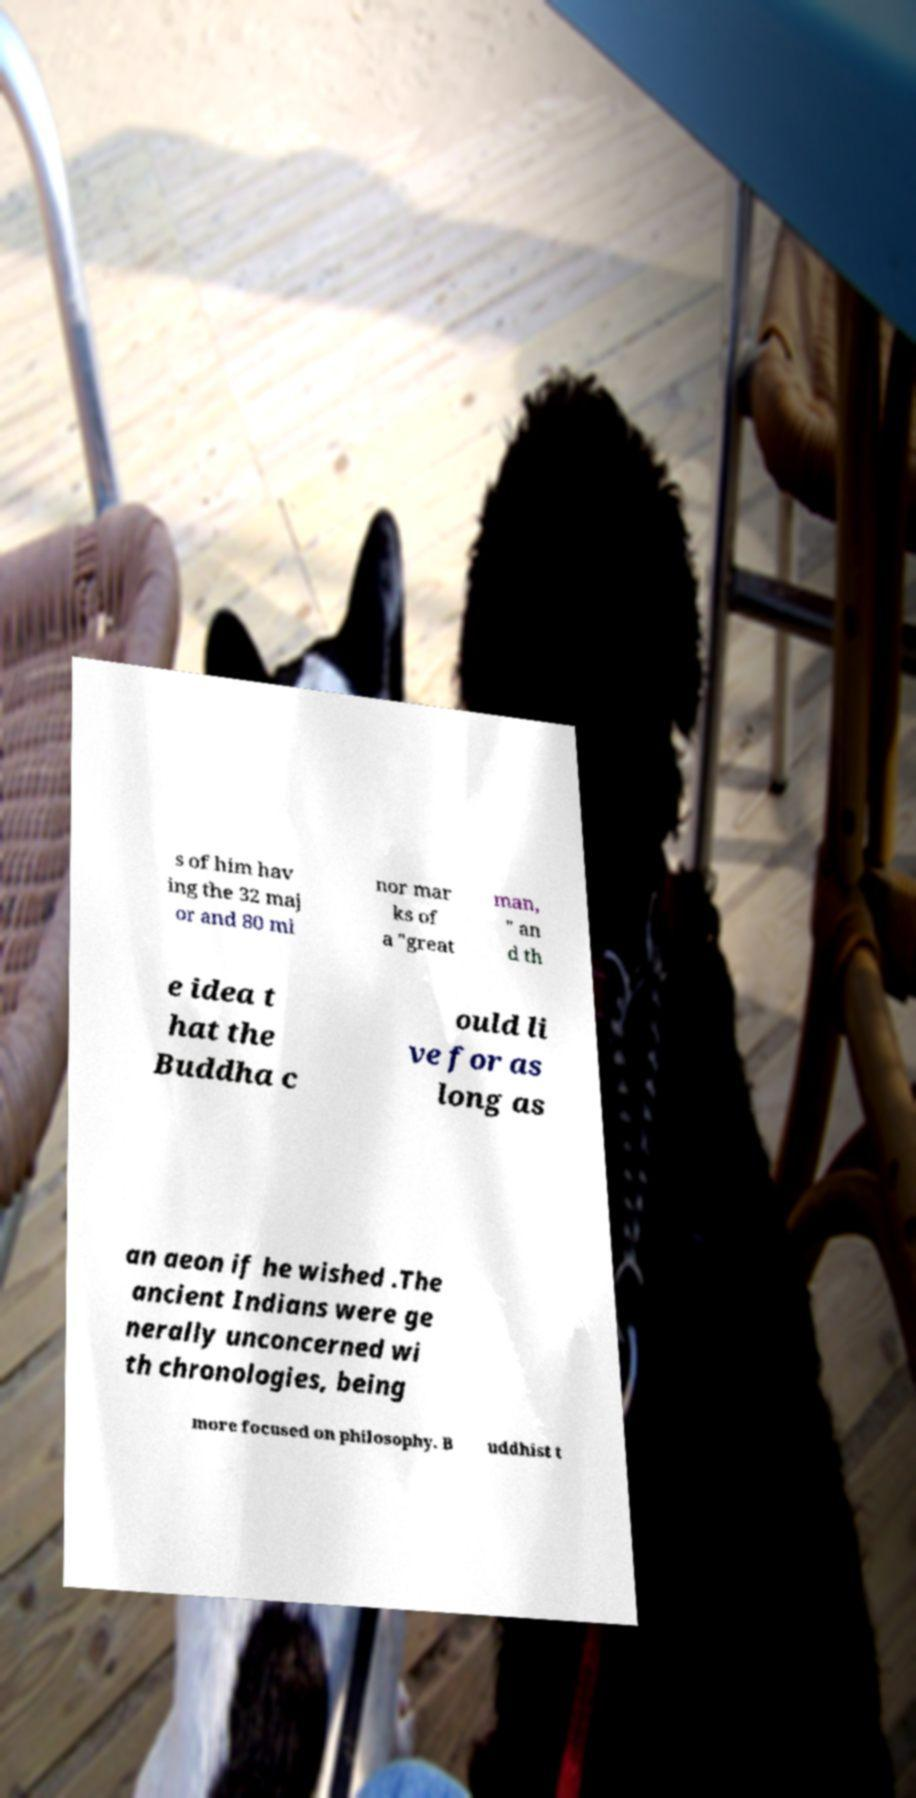Please identify and transcribe the text found in this image. s of him hav ing the 32 maj or and 80 mi nor mar ks of a "great man, " an d th e idea t hat the Buddha c ould li ve for as long as an aeon if he wished .The ancient Indians were ge nerally unconcerned wi th chronologies, being more focused on philosophy. B uddhist t 